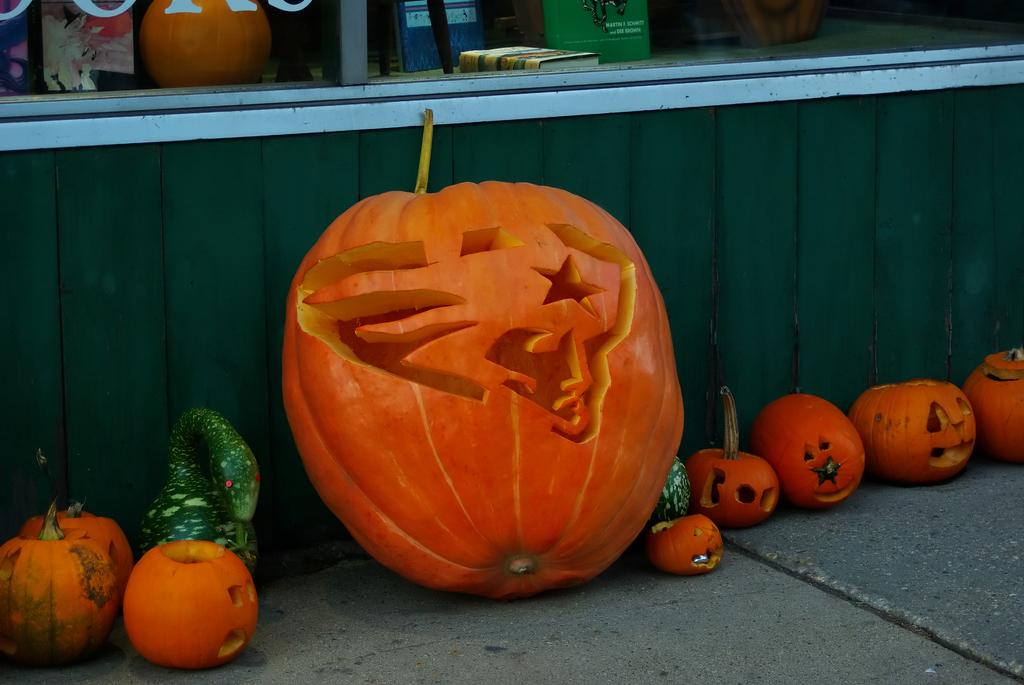What color are the pumpkins on the floor in the image? The pumpkins on the floor are orange in color. Can you describe any objects visible in the background of the image? Unfortunately, the provided facts do not give any information about the objects in the background. How many dolls are sitting on the twig in the image? There are no dolls or twigs present in the image. 